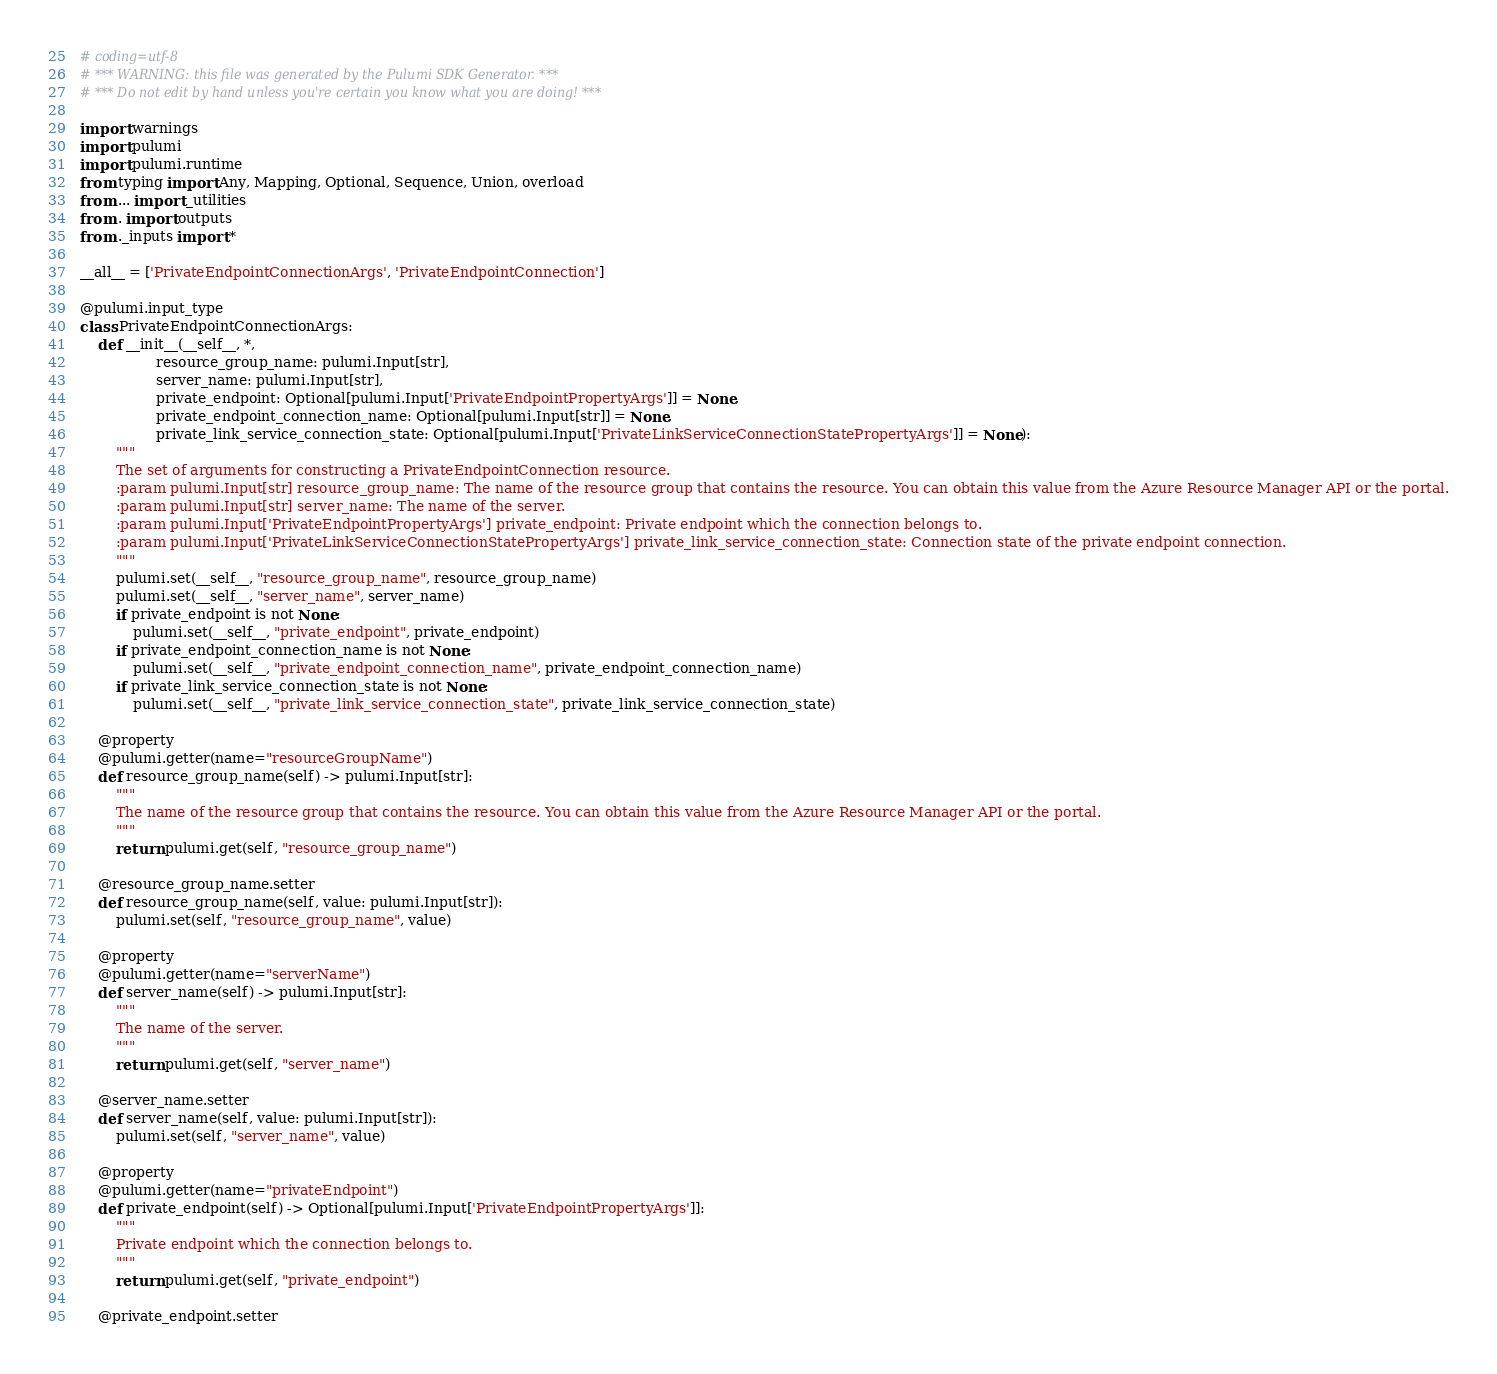Convert code to text. <code><loc_0><loc_0><loc_500><loc_500><_Python_># coding=utf-8
# *** WARNING: this file was generated by the Pulumi SDK Generator. ***
# *** Do not edit by hand unless you're certain you know what you are doing! ***

import warnings
import pulumi
import pulumi.runtime
from typing import Any, Mapping, Optional, Sequence, Union, overload
from ... import _utilities
from . import outputs
from ._inputs import *

__all__ = ['PrivateEndpointConnectionArgs', 'PrivateEndpointConnection']

@pulumi.input_type
class PrivateEndpointConnectionArgs:
    def __init__(__self__, *,
                 resource_group_name: pulumi.Input[str],
                 server_name: pulumi.Input[str],
                 private_endpoint: Optional[pulumi.Input['PrivateEndpointPropertyArgs']] = None,
                 private_endpoint_connection_name: Optional[pulumi.Input[str]] = None,
                 private_link_service_connection_state: Optional[pulumi.Input['PrivateLinkServiceConnectionStatePropertyArgs']] = None):
        """
        The set of arguments for constructing a PrivateEndpointConnection resource.
        :param pulumi.Input[str] resource_group_name: The name of the resource group that contains the resource. You can obtain this value from the Azure Resource Manager API or the portal.
        :param pulumi.Input[str] server_name: The name of the server.
        :param pulumi.Input['PrivateEndpointPropertyArgs'] private_endpoint: Private endpoint which the connection belongs to.
        :param pulumi.Input['PrivateLinkServiceConnectionStatePropertyArgs'] private_link_service_connection_state: Connection state of the private endpoint connection.
        """
        pulumi.set(__self__, "resource_group_name", resource_group_name)
        pulumi.set(__self__, "server_name", server_name)
        if private_endpoint is not None:
            pulumi.set(__self__, "private_endpoint", private_endpoint)
        if private_endpoint_connection_name is not None:
            pulumi.set(__self__, "private_endpoint_connection_name", private_endpoint_connection_name)
        if private_link_service_connection_state is not None:
            pulumi.set(__self__, "private_link_service_connection_state", private_link_service_connection_state)

    @property
    @pulumi.getter(name="resourceGroupName")
    def resource_group_name(self) -> pulumi.Input[str]:
        """
        The name of the resource group that contains the resource. You can obtain this value from the Azure Resource Manager API or the portal.
        """
        return pulumi.get(self, "resource_group_name")

    @resource_group_name.setter
    def resource_group_name(self, value: pulumi.Input[str]):
        pulumi.set(self, "resource_group_name", value)

    @property
    @pulumi.getter(name="serverName")
    def server_name(self) -> pulumi.Input[str]:
        """
        The name of the server.
        """
        return pulumi.get(self, "server_name")

    @server_name.setter
    def server_name(self, value: pulumi.Input[str]):
        pulumi.set(self, "server_name", value)

    @property
    @pulumi.getter(name="privateEndpoint")
    def private_endpoint(self) -> Optional[pulumi.Input['PrivateEndpointPropertyArgs']]:
        """
        Private endpoint which the connection belongs to.
        """
        return pulumi.get(self, "private_endpoint")

    @private_endpoint.setter</code> 